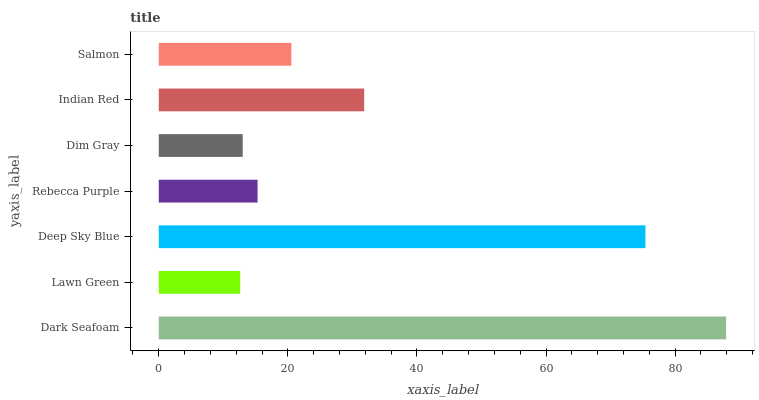Is Lawn Green the minimum?
Answer yes or no. Yes. Is Dark Seafoam the maximum?
Answer yes or no. Yes. Is Deep Sky Blue the minimum?
Answer yes or no. No. Is Deep Sky Blue the maximum?
Answer yes or no. No. Is Deep Sky Blue greater than Lawn Green?
Answer yes or no. Yes. Is Lawn Green less than Deep Sky Blue?
Answer yes or no. Yes. Is Lawn Green greater than Deep Sky Blue?
Answer yes or no. No. Is Deep Sky Blue less than Lawn Green?
Answer yes or no. No. Is Salmon the high median?
Answer yes or no. Yes. Is Salmon the low median?
Answer yes or no. Yes. Is Dim Gray the high median?
Answer yes or no. No. Is Lawn Green the low median?
Answer yes or no. No. 